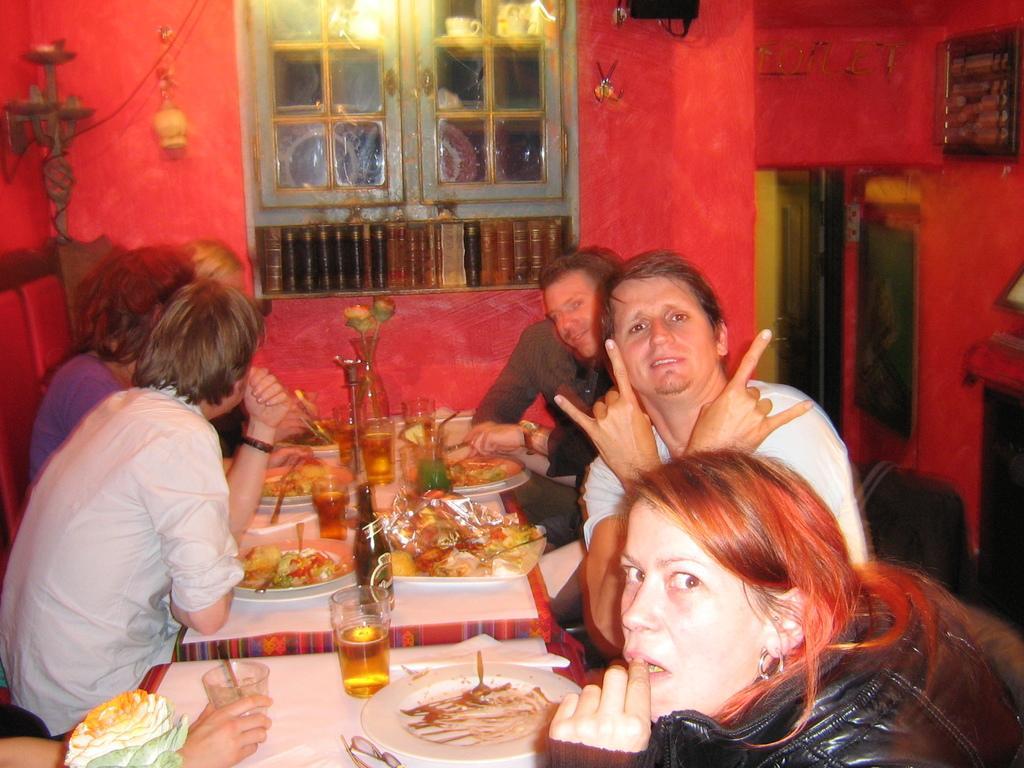In one or two sentences, can you explain what this image depicts? In this picture there are several people sitting on the table with food items kept on top of it. The background is red in color. 